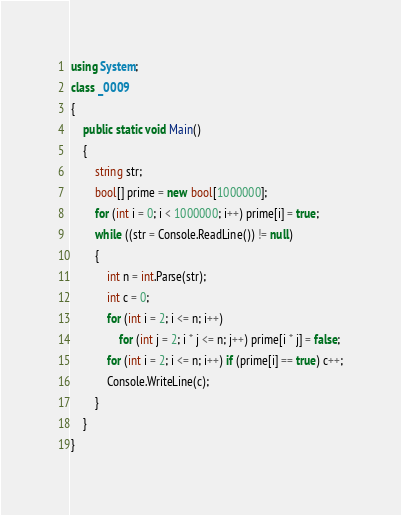Convert code to text. <code><loc_0><loc_0><loc_500><loc_500><_C#_>using System;
class _0009
{
    public static void Main()
    {
        string str;
        bool[] prime = new bool[1000000];
        for (int i = 0; i < 1000000; i++) prime[i] = true;
        while ((str = Console.ReadLine()) != null)
        {
            int n = int.Parse(str);
            int c = 0;
            for (int i = 2; i <= n; i++)
                for (int j = 2; i * j <= n; j++) prime[i * j] = false;
            for (int i = 2; i <= n; i++) if (prime[i] == true) c++;
            Console.WriteLine(c);
        }
    }
}</code> 